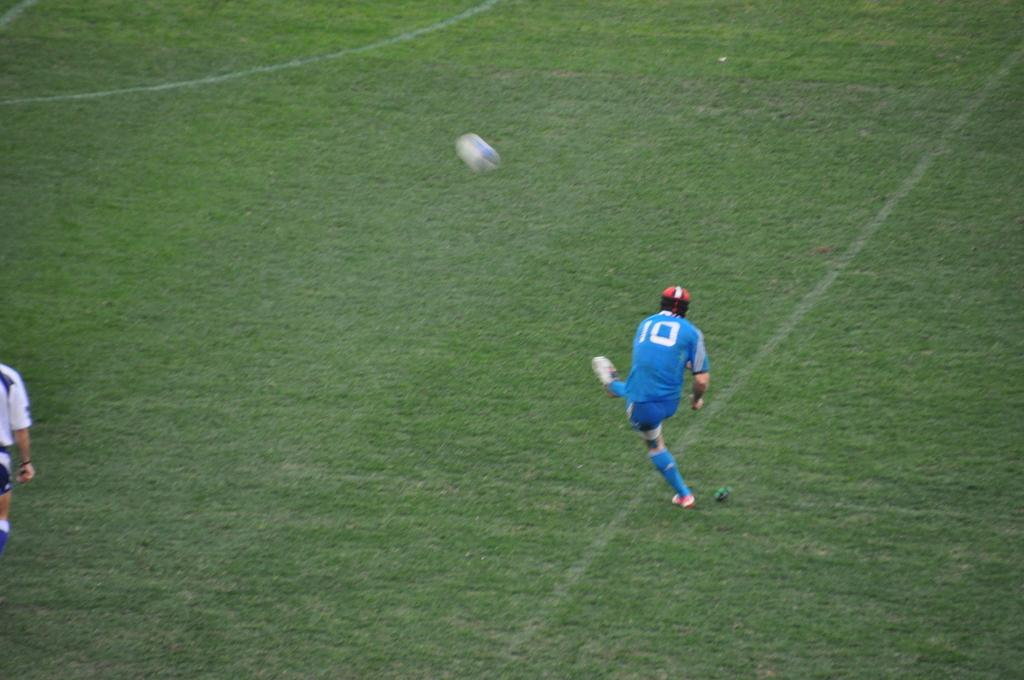How many people are in the image? There are two persons in the image. What is the position of the persons in the image? The persons are on the ground. What object is present in the image along with the persons? There is a ball in the image. What type of alarm can be heard going off in the image? There is no alarm present or audible in the image. What kind of silk material is draped over the persons in the image? There is no silk material present in the image. 